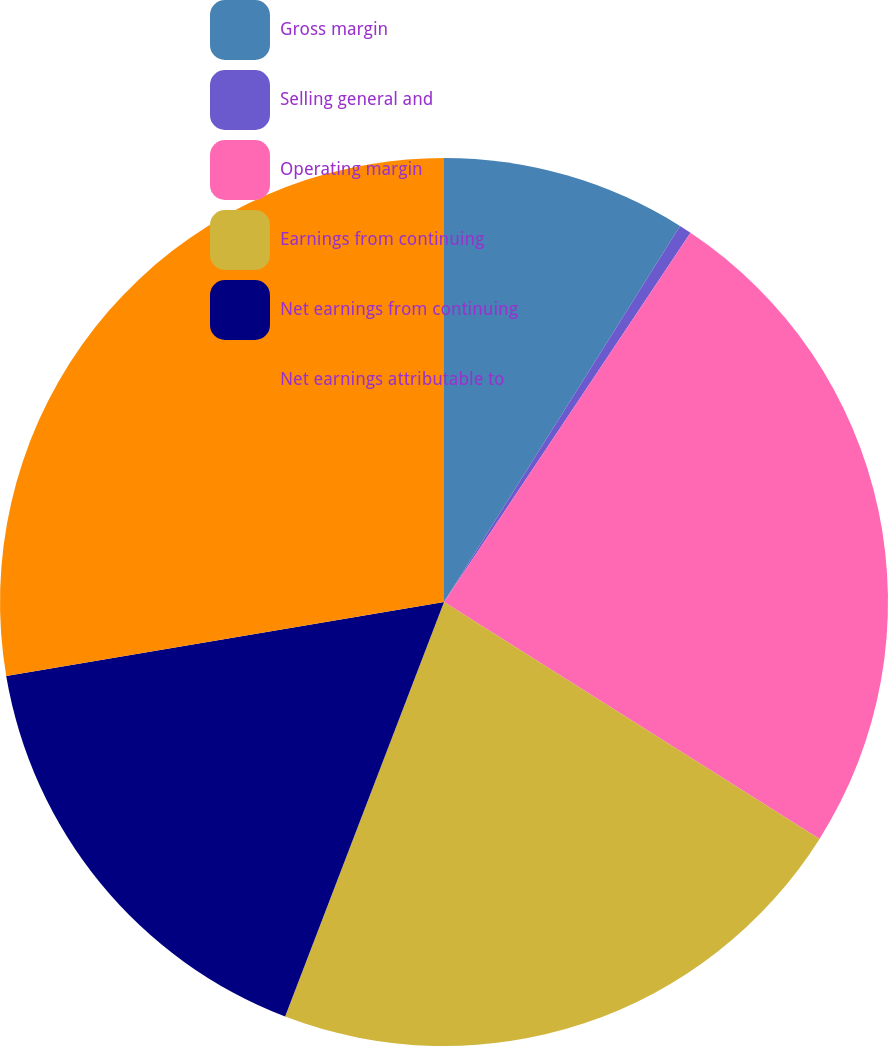<chart> <loc_0><loc_0><loc_500><loc_500><pie_chart><fcel>Gross margin<fcel>Selling general and<fcel>Operating margin<fcel>Earnings from continuing<fcel>Net earnings from continuing<fcel>Net earnings attributable to<nl><fcel>8.92%<fcel>0.45%<fcel>24.59%<fcel>21.87%<fcel>16.51%<fcel>27.67%<nl></chart> 